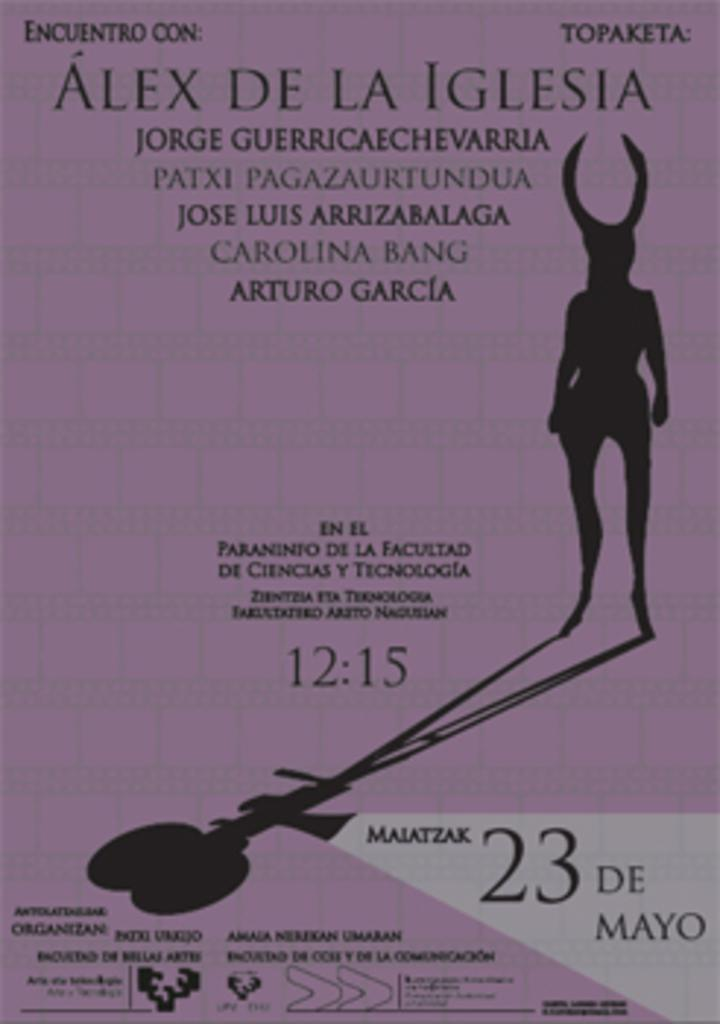What type of object is visible in the image? There is an object in the image that appears to be a poster. What can be found on the poster? The poster contains text, numbers, and pictures of objects. What type of thrill can be seen on the poster? There is no mention of a thrill or any related activity on the poster. The poster contains text, numbers, and pictures of objects. 